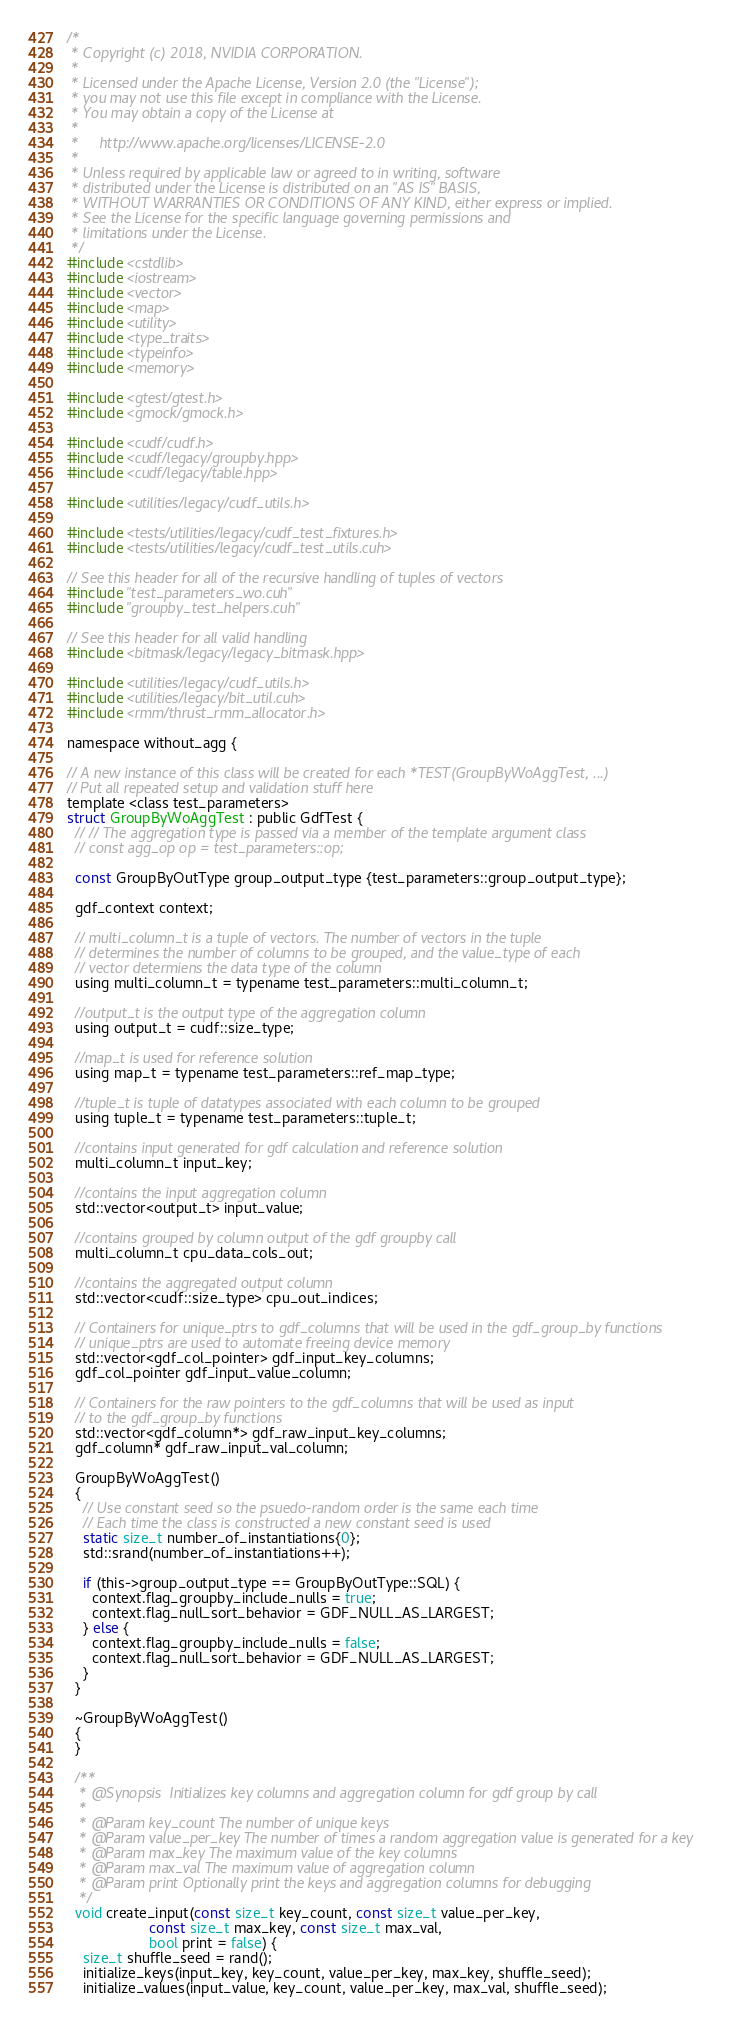Convert code to text. <code><loc_0><loc_0><loc_500><loc_500><_Cuda_>/*
 * Copyright (c) 2018, NVIDIA CORPORATION.
 *
 * Licensed under the Apache License, Version 2.0 (the "License");
 * you may not use this file except in compliance with the License.
 * You may obtain a copy of the License at
 *
 *     http://www.apache.org/licenses/LICENSE-2.0
 *
 * Unless required by applicable law or agreed to in writing, software
 * distributed under the License is distributed on an "AS IS" BASIS,
 * WITHOUT WARRANTIES OR CONDITIONS OF ANY KIND, either express or implied.
 * See the License for the specific language governing permissions and
 * limitations under the License.
 */
#include <cstdlib>
#include <iostream>
#include <vector>
#include <map>
#include <utility>
#include <type_traits>
#include <typeinfo>
#include <memory>

#include <gtest/gtest.h>
#include <gmock/gmock.h>

#include <cudf/cudf.h>
#include <cudf/legacy/groupby.hpp>
#include <cudf/legacy/table.hpp>

#include <utilities/legacy/cudf_utils.h>

#include <tests/utilities/legacy/cudf_test_fixtures.h>
#include <tests/utilities/legacy/cudf_test_utils.cuh>

// See this header for all of the recursive handling of tuples of vectors
#include "test_parameters_wo.cuh"
#include "groupby_test_helpers.cuh"

// See this header for all valid handling
#include <bitmask/legacy/legacy_bitmask.hpp>

#include <utilities/legacy/cudf_utils.h>
#include <utilities/legacy/bit_util.cuh>
#include <rmm/thrust_rmm_allocator.h>

namespace without_agg {

// A new instance of this class will be created for each *TEST(GroupByWoAggTest, ...)
// Put all repeated setup and validation stuff here
template <class test_parameters>
struct GroupByWoAggTest : public GdfTest {
  // // The aggregation type is passed via a member of the template argument class
  // const agg_op op = test_parameters::op;

  const GroupByOutType group_output_type {test_parameters::group_output_type};

  gdf_context context;

  // multi_column_t is a tuple of vectors. The number of vectors in the tuple
  // determines the number of columns to be grouped, and the value_type of each
  // vector determiens the data type of the column
  using multi_column_t = typename test_parameters::multi_column_t;

  //output_t is the output type of the aggregation column
  using output_t = cudf::size_type;

  //map_t is used for reference solution
  using map_t = typename test_parameters::ref_map_type;

  //tuple_t is tuple of datatypes associated with each column to be grouped
  using tuple_t = typename test_parameters::tuple_t;

  //contains input generated for gdf calculation and reference solution
  multi_column_t input_key;

  //contains the input aggregation column
  std::vector<output_t> input_value;

  //contains grouped by column output of the gdf groupby call
  multi_column_t cpu_data_cols_out;

  //contains the aggregated output column
  std::vector<cudf::size_type> cpu_out_indices;

  // Containers for unique_ptrs to gdf_columns that will be used in the gdf_group_by functions
  // unique_ptrs are used to automate freeing device memory
  std::vector<gdf_col_pointer> gdf_input_key_columns;
  gdf_col_pointer gdf_input_value_column;

  // Containers for the raw pointers to the gdf_columns that will be used as input
  // to the gdf_group_by functions
  std::vector<gdf_column*> gdf_raw_input_key_columns;
  gdf_column* gdf_raw_input_val_column;

  GroupByWoAggTest()
  {
    // Use constant seed so the psuedo-random order is the same each time
    // Each time the class is constructed a new constant seed is used
    static size_t number_of_instantiations{0};
    std::srand(number_of_instantiations++);

    if (this->group_output_type == GroupByOutType::SQL) {
      context.flag_groupby_include_nulls = true;
      context.flag_null_sort_behavior = GDF_NULL_AS_LARGEST;
    } else {
      context.flag_groupby_include_nulls = false;
      context.flag_null_sort_behavior = GDF_NULL_AS_LARGEST;
    }
  }

  ~GroupByWoAggTest()
  {
  }

  /**
   * @Synopsis  Initializes key columns and aggregation column for gdf group by call
   *
   * @Param key_count The number of unique keys
   * @Param value_per_key The number of times a random aggregation value is generated for a key
   * @Param max_key The maximum value of the key columns
   * @Param max_val The maximum value of aggregation column
   * @Param print Optionally print the keys and aggregation columns for debugging
   */
  void create_input(const size_t key_count, const size_t value_per_key,
                    const size_t max_key, const size_t max_val,
                    bool print = false) {
    size_t shuffle_seed = rand();
    initialize_keys(input_key, key_count, value_per_key, max_key, shuffle_seed);
    initialize_values(input_value, key_count, value_per_key, max_val, shuffle_seed);
</code> 